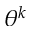Convert formula to latex. <formula><loc_0><loc_0><loc_500><loc_500>\theta ^ { k }</formula> 